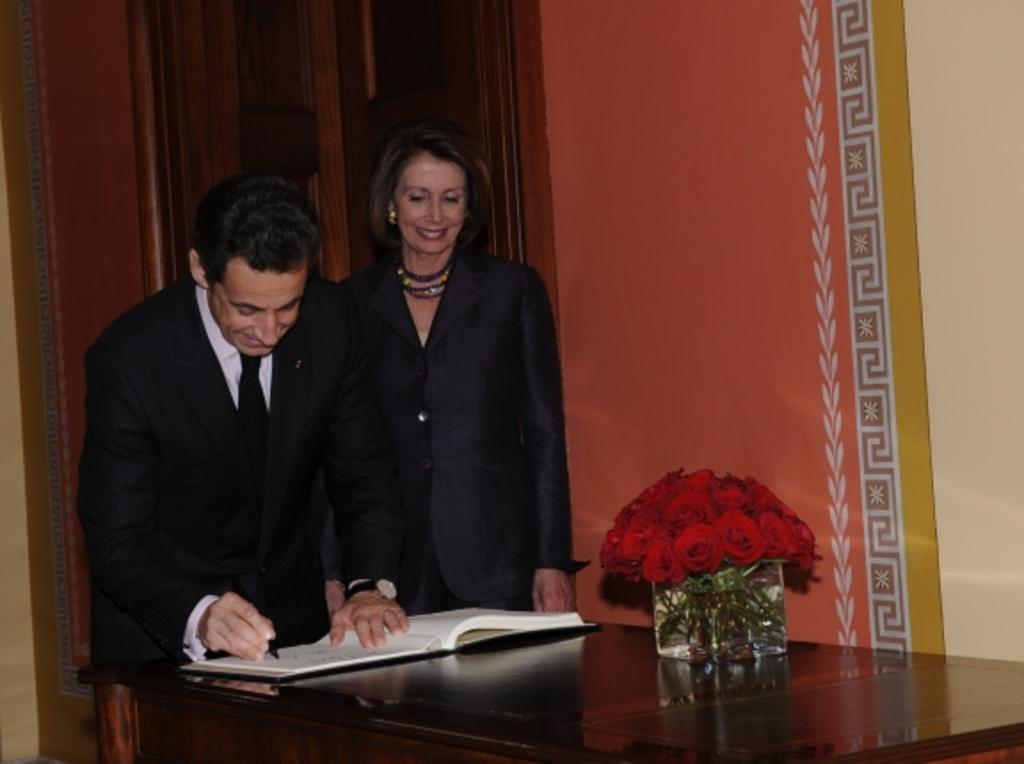What is the person on the left side of the image doing? The person is writing in a book. Where is the book located? The book is on a table. Who is standing beside the person writing in the book? There is another woman standing beside the person. What else can be seen on the table? There is a flower vase on the table. What type of chalk is the person using to write in the book? There is no chalk present in the image; the person is writing in the book with a pen or pencil. What are the hobbies of the person and the woman standing beside them? The provided facts do not give information about the hobbies of the person or the woman standing beside them. 